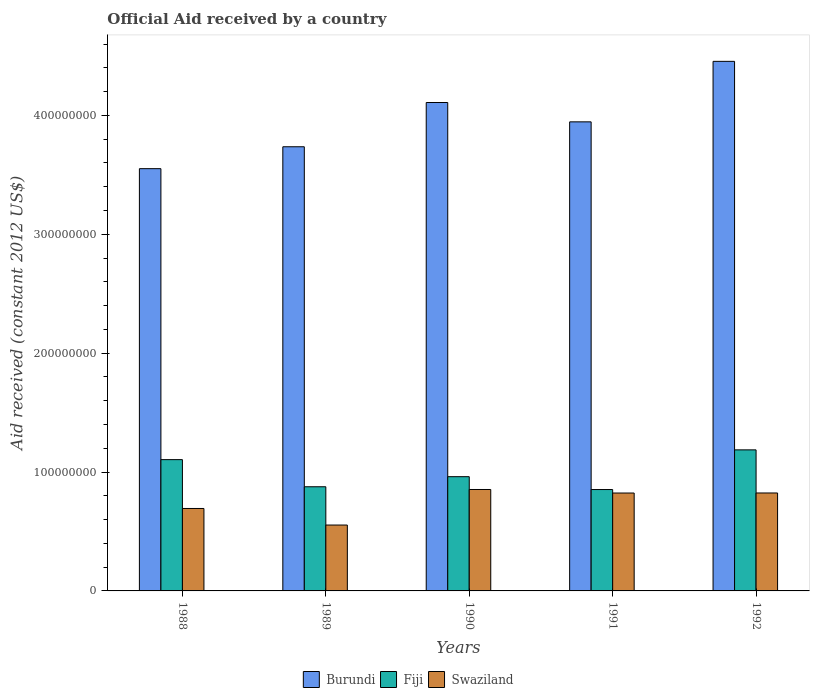How many different coloured bars are there?
Provide a short and direct response. 3. Are the number of bars per tick equal to the number of legend labels?
Ensure brevity in your answer.  Yes. What is the net official aid received in Fiji in 1988?
Your answer should be very brief. 1.10e+08. Across all years, what is the maximum net official aid received in Swaziland?
Offer a very short reply. 8.53e+07. Across all years, what is the minimum net official aid received in Swaziland?
Give a very brief answer. 5.54e+07. What is the total net official aid received in Burundi in the graph?
Offer a terse response. 1.98e+09. What is the difference between the net official aid received in Burundi in 1989 and that in 1990?
Ensure brevity in your answer.  -3.72e+07. What is the difference between the net official aid received in Swaziland in 1988 and the net official aid received in Fiji in 1992?
Your answer should be compact. -4.93e+07. What is the average net official aid received in Fiji per year?
Ensure brevity in your answer.  9.96e+07. In the year 1990, what is the difference between the net official aid received in Swaziland and net official aid received in Fiji?
Ensure brevity in your answer.  -1.08e+07. What is the ratio of the net official aid received in Fiji in 1988 to that in 1991?
Offer a very short reply. 1.29. Is the net official aid received in Burundi in 1988 less than that in 1990?
Give a very brief answer. Yes. What is the difference between the highest and the second highest net official aid received in Fiji?
Ensure brevity in your answer.  8.22e+06. What is the difference between the highest and the lowest net official aid received in Fiji?
Make the answer very short. 3.34e+07. Is the sum of the net official aid received in Burundi in 1991 and 1992 greater than the maximum net official aid received in Swaziland across all years?
Your response must be concise. Yes. What does the 1st bar from the left in 1990 represents?
Your response must be concise. Burundi. What does the 1st bar from the right in 1989 represents?
Your answer should be compact. Swaziland. Is it the case that in every year, the sum of the net official aid received in Fiji and net official aid received in Burundi is greater than the net official aid received in Swaziland?
Ensure brevity in your answer.  Yes. What is the difference between two consecutive major ticks on the Y-axis?
Make the answer very short. 1.00e+08. Does the graph contain any zero values?
Offer a very short reply. No. How are the legend labels stacked?
Make the answer very short. Horizontal. What is the title of the graph?
Your answer should be compact. Official Aid received by a country. What is the label or title of the Y-axis?
Make the answer very short. Aid received (constant 2012 US$). What is the Aid received (constant 2012 US$) in Burundi in 1988?
Your response must be concise. 3.55e+08. What is the Aid received (constant 2012 US$) of Fiji in 1988?
Your answer should be compact. 1.10e+08. What is the Aid received (constant 2012 US$) in Swaziland in 1988?
Your response must be concise. 6.94e+07. What is the Aid received (constant 2012 US$) in Burundi in 1989?
Make the answer very short. 3.74e+08. What is the Aid received (constant 2012 US$) in Fiji in 1989?
Keep it short and to the point. 8.76e+07. What is the Aid received (constant 2012 US$) in Swaziland in 1989?
Provide a short and direct response. 5.54e+07. What is the Aid received (constant 2012 US$) of Burundi in 1990?
Give a very brief answer. 4.11e+08. What is the Aid received (constant 2012 US$) in Fiji in 1990?
Provide a short and direct response. 9.61e+07. What is the Aid received (constant 2012 US$) of Swaziland in 1990?
Your answer should be very brief. 8.53e+07. What is the Aid received (constant 2012 US$) in Burundi in 1991?
Your answer should be very brief. 3.95e+08. What is the Aid received (constant 2012 US$) of Fiji in 1991?
Provide a short and direct response. 8.53e+07. What is the Aid received (constant 2012 US$) in Swaziland in 1991?
Your answer should be very brief. 8.24e+07. What is the Aid received (constant 2012 US$) in Burundi in 1992?
Your answer should be compact. 4.45e+08. What is the Aid received (constant 2012 US$) in Fiji in 1992?
Keep it short and to the point. 1.19e+08. What is the Aid received (constant 2012 US$) of Swaziland in 1992?
Offer a very short reply. 8.24e+07. Across all years, what is the maximum Aid received (constant 2012 US$) of Burundi?
Keep it short and to the point. 4.45e+08. Across all years, what is the maximum Aid received (constant 2012 US$) of Fiji?
Offer a very short reply. 1.19e+08. Across all years, what is the maximum Aid received (constant 2012 US$) in Swaziland?
Give a very brief answer. 8.53e+07. Across all years, what is the minimum Aid received (constant 2012 US$) of Burundi?
Your answer should be very brief. 3.55e+08. Across all years, what is the minimum Aid received (constant 2012 US$) in Fiji?
Keep it short and to the point. 8.53e+07. Across all years, what is the minimum Aid received (constant 2012 US$) in Swaziland?
Your answer should be very brief. 5.54e+07. What is the total Aid received (constant 2012 US$) of Burundi in the graph?
Your response must be concise. 1.98e+09. What is the total Aid received (constant 2012 US$) of Fiji in the graph?
Your answer should be compact. 4.98e+08. What is the total Aid received (constant 2012 US$) in Swaziland in the graph?
Ensure brevity in your answer.  3.75e+08. What is the difference between the Aid received (constant 2012 US$) in Burundi in 1988 and that in 1989?
Your answer should be very brief. -1.84e+07. What is the difference between the Aid received (constant 2012 US$) in Fiji in 1988 and that in 1989?
Your response must be concise. 2.28e+07. What is the difference between the Aid received (constant 2012 US$) in Swaziland in 1988 and that in 1989?
Your answer should be very brief. 1.39e+07. What is the difference between the Aid received (constant 2012 US$) in Burundi in 1988 and that in 1990?
Your response must be concise. -5.56e+07. What is the difference between the Aid received (constant 2012 US$) of Fiji in 1988 and that in 1990?
Your response must be concise. 1.43e+07. What is the difference between the Aid received (constant 2012 US$) of Swaziland in 1988 and that in 1990?
Make the answer very short. -1.60e+07. What is the difference between the Aid received (constant 2012 US$) in Burundi in 1988 and that in 1991?
Make the answer very short. -3.94e+07. What is the difference between the Aid received (constant 2012 US$) of Fiji in 1988 and that in 1991?
Provide a succinct answer. 2.52e+07. What is the difference between the Aid received (constant 2012 US$) of Swaziland in 1988 and that in 1991?
Provide a short and direct response. -1.30e+07. What is the difference between the Aid received (constant 2012 US$) in Burundi in 1988 and that in 1992?
Provide a short and direct response. -9.03e+07. What is the difference between the Aid received (constant 2012 US$) in Fiji in 1988 and that in 1992?
Give a very brief answer. -8.22e+06. What is the difference between the Aid received (constant 2012 US$) of Swaziland in 1988 and that in 1992?
Offer a terse response. -1.30e+07. What is the difference between the Aid received (constant 2012 US$) of Burundi in 1989 and that in 1990?
Provide a short and direct response. -3.72e+07. What is the difference between the Aid received (constant 2012 US$) in Fiji in 1989 and that in 1990?
Your response must be concise. -8.49e+06. What is the difference between the Aid received (constant 2012 US$) in Swaziland in 1989 and that in 1990?
Ensure brevity in your answer.  -2.99e+07. What is the difference between the Aid received (constant 2012 US$) of Burundi in 1989 and that in 1991?
Offer a terse response. -2.10e+07. What is the difference between the Aid received (constant 2012 US$) in Fiji in 1989 and that in 1991?
Your answer should be very brief. 2.33e+06. What is the difference between the Aid received (constant 2012 US$) of Swaziland in 1989 and that in 1991?
Provide a succinct answer. -2.69e+07. What is the difference between the Aid received (constant 2012 US$) in Burundi in 1989 and that in 1992?
Keep it short and to the point. -7.18e+07. What is the difference between the Aid received (constant 2012 US$) of Fiji in 1989 and that in 1992?
Provide a succinct answer. -3.10e+07. What is the difference between the Aid received (constant 2012 US$) in Swaziland in 1989 and that in 1992?
Your answer should be very brief. -2.70e+07. What is the difference between the Aid received (constant 2012 US$) in Burundi in 1990 and that in 1991?
Keep it short and to the point. 1.63e+07. What is the difference between the Aid received (constant 2012 US$) of Fiji in 1990 and that in 1991?
Give a very brief answer. 1.08e+07. What is the difference between the Aid received (constant 2012 US$) of Swaziland in 1990 and that in 1991?
Offer a very short reply. 2.97e+06. What is the difference between the Aid received (constant 2012 US$) in Burundi in 1990 and that in 1992?
Your answer should be compact. -3.46e+07. What is the difference between the Aid received (constant 2012 US$) of Fiji in 1990 and that in 1992?
Provide a succinct answer. -2.26e+07. What is the difference between the Aid received (constant 2012 US$) of Swaziland in 1990 and that in 1992?
Provide a short and direct response. 2.93e+06. What is the difference between the Aid received (constant 2012 US$) of Burundi in 1991 and that in 1992?
Offer a very short reply. -5.09e+07. What is the difference between the Aid received (constant 2012 US$) of Fiji in 1991 and that in 1992?
Provide a succinct answer. -3.34e+07. What is the difference between the Aid received (constant 2012 US$) of Burundi in 1988 and the Aid received (constant 2012 US$) of Fiji in 1989?
Offer a very short reply. 2.68e+08. What is the difference between the Aid received (constant 2012 US$) in Burundi in 1988 and the Aid received (constant 2012 US$) in Swaziland in 1989?
Provide a succinct answer. 3.00e+08. What is the difference between the Aid received (constant 2012 US$) in Fiji in 1988 and the Aid received (constant 2012 US$) in Swaziland in 1989?
Your answer should be very brief. 5.50e+07. What is the difference between the Aid received (constant 2012 US$) of Burundi in 1988 and the Aid received (constant 2012 US$) of Fiji in 1990?
Offer a terse response. 2.59e+08. What is the difference between the Aid received (constant 2012 US$) in Burundi in 1988 and the Aid received (constant 2012 US$) in Swaziland in 1990?
Your answer should be very brief. 2.70e+08. What is the difference between the Aid received (constant 2012 US$) in Fiji in 1988 and the Aid received (constant 2012 US$) in Swaziland in 1990?
Provide a succinct answer. 2.51e+07. What is the difference between the Aid received (constant 2012 US$) of Burundi in 1988 and the Aid received (constant 2012 US$) of Fiji in 1991?
Give a very brief answer. 2.70e+08. What is the difference between the Aid received (constant 2012 US$) in Burundi in 1988 and the Aid received (constant 2012 US$) in Swaziland in 1991?
Provide a succinct answer. 2.73e+08. What is the difference between the Aid received (constant 2012 US$) of Fiji in 1988 and the Aid received (constant 2012 US$) of Swaziland in 1991?
Make the answer very short. 2.81e+07. What is the difference between the Aid received (constant 2012 US$) of Burundi in 1988 and the Aid received (constant 2012 US$) of Fiji in 1992?
Provide a succinct answer. 2.37e+08. What is the difference between the Aid received (constant 2012 US$) in Burundi in 1988 and the Aid received (constant 2012 US$) in Swaziland in 1992?
Keep it short and to the point. 2.73e+08. What is the difference between the Aid received (constant 2012 US$) in Fiji in 1988 and the Aid received (constant 2012 US$) in Swaziland in 1992?
Offer a terse response. 2.80e+07. What is the difference between the Aid received (constant 2012 US$) in Burundi in 1989 and the Aid received (constant 2012 US$) in Fiji in 1990?
Provide a short and direct response. 2.78e+08. What is the difference between the Aid received (constant 2012 US$) of Burundi in 1989 and the Aid received (constant 2012 US$) of Swaziland in 1990?
Provide a succinct answer. 2.88e+08. What is the difference between the Aid received (constant 2012 US$) in Fiji in 1989 and the Aid received (constant 2012 US$) in Swaziland in 1990?
Your answer should be compact. 2.30e+06. What is the difference between the Aid received (constant 2012 US$) in Burundi in 1989 and the Aid received (constant 2012 US$) in Fiji in 1991?
Your answer should be compact. 2.88e+08. What is the difference between the Aid received (constant 2012 US$) in Burundi in 1989 and the Aid received (constant 2012 US$) in Swaziland in 1991?
Your answer should be very brief. 2.91e+08. What is the difference between the Aid received (constant 2012 US$) in Fiji in 1989 and the Aid received (constant 2012 US$) in Swaziland in 1991?
Your answer should be compact. 5.27e+06. What is the difference between the Aid received (constant 2012 US$) in Burundi in 1989 and the Aid received (constant 2012 US$) in Fiji in 1992?
Ensure brevity in your answer.  2.55e+08. What is the difference between the Aid received (constant 2012 US$) of Burundi in 1989 and the Aid received (constant 2012 US$) of Swaziland in 1992?
Give a very brief answer. 2.91e+08. What is the difference between the Aid received (constant 2012 US$) of Fiji in 1989 and the Aid received (constant 2012 US$) of Swaziland in 1992?
Keep it short and to the point. 5.23e+06. What is the difference between the Aid received (constant 2012 US$) of Burundi in 1990 and the Aid received (constant 2012 US$) of Fiji in 1991?
Your answer should be compact. 3.26e+08. What is the difference between the Aid received (constant 2012 US$) of Burundi in 1990 and the Aid received (constant 2012 US$) of Swaziland in 1991?
Your answer should be compact. 3.29e+08. What is the difference between the Aid received (constant 2012 US$) in Fiji in 1990 and the Aid received (constant 2012 US$) in Swaziland in 1991?
Your answer should be compact. 1.38e+07. What is the difference between the Aid received (constant 2012 US$) of Burundi in 1990 and the Aid received (constant 2012 US$) of Fiji in 1992?
Give a very brief answer. 2.92e+08. What is the difference between the Aid received (constant 2012 US$) in Burundi in 1990 and the Aid received (constant 2012 US$) in Swaziland in 1992?
Offer a terse response. 3.28e+08. What is the difference between the Aid received (constant 2012 US$) in Fiji in 1990 and the Aid received (constant 2012 US$) in Swaziland in 1992?
Keep it short and to the point. 1.37e+07. What is the difference between the Aid received (constant 2012 US$) of Burundi in 1991 and the Aid received (constant 2012 US$) of Fiji in 1992?
Your response must be concise. 2.76e+08. What is the difference between the Aid received (constant 2012 US$) in Burundi in 1991 and the Aid received (constant 2012 US$) in Swaziland in 1992?
Keep it short and to the point. 3.12e+08. What is the difference between the Aid received (constant 2012 US$) of Fiji in 1991 and the Aid received (constant 2012 US$) of Swaziland in 1992?
Keep it short and to the point. 2.90e+06. What is the average Aid received (constant 2012 US$) of Burundi per year?
Provide a succinct answer. 3.96e+08. What is the average Aid received (constant 2012 US$) in Fiji per year?
Provide a succinct answer. 9.96e+07. What is the average Aid received (constant 2012 US$) of Swaziland per year?
Ensure brevity in your answer.  7.50e+07. In the year 1988, what is the difference between the Aid received (constant 2012 US$) of Burundi and Aid received (constant 2012 US$) of Fiji?
Provide a short and direct response. 2.45e+08. In the year 1988, what is the difference between the Aid received (constant 2012 US$) of Burundi and Aid received (constant 2012 US$) of Swaziland?
Give a very brief answer. 2.86e+08. In the year 1988, what is the difference between the Aid received (constant 2012 US$) of Fiji and Aid received (constant 2012 US$) of Swaziland?
Make the answer very short. 4.11e+07. In the year 1989, what is the difference between the Aid received (constant 2012 US$) of Burundi and Aid received (constant 2012 US$) of Fiji?
Your response must be concise. 2.86e+08. In the year 1989, what is the difference between the Aid received (constant 2012 US$) in Burundi and Aid received (constant 2012 US$) in Swaziland?
Provide a succinct answer. 3.18e+08. In the year 1989, what is the difference between the Aid received (constant 2012 US$) of Fiji and Aid received (constant 2012 US$) of Swaziland?
Make the answer very short. 3.22e+07. In the year 1990, what is the difference between the Aid received (constant 2012 US$) of Burundi and Aid received (constant 2012 US$) of Fiji?
Ensure brevity in your answer.  3.15e+08. In the year 1990, what is the difference between the Aid received (constant 2012 US$) of Burundi and Aid received (constant 2012 US$) of Swaziland?
Give a very brief answer. 3.26e+08. In the year 1990, what is the difference between the Aid received (constant 2012 US$) in Fiji and Aid received (constant 2012 US$) in Swaziland?
Give a very brief answer. 1.08e+07. In the year 1991, what is the difference between the Aid received (constant 2012 US$) of Burundi and Aid received (constant 2012 US$) of Fiji?
Your answer should be compact. 3.09e+08. In the year 1991, what is the difference between the Aid received (constant 2012 US$) of Burundi and Aid received (constant 2012 US$) of Swaziland?
Keep it short and to the point. 3.12e+08. In the year 1991, what is the difference between the Aid received (constant 2012 US$) of Fiji and Aid received (constant 2012 US$) of Swaziland?
Keep it short and to the point. 2.94e+06. In the year 1992, what is the difference between the Aid received (constant 2012 US$) of Burundi and Aid received (constant 2012 US$) of Fiji?
Give a very brief answer. 3.27e+08. In the year 1992, what is the difference between the Aid received (constant 2012 US$) of Burundi and Aid received (constant 2012 US$) of Swaziland?
Ensure brevity in your answer.  3.63e+08. In the year 1992, what is the difference between the Aid received (constant 2012 US$) in Fiji and Aid received (constant 2012 US$) in Swaziland?
Give a very brief answer. 3.63e+07. What is the ratio of the Aid received (constant 2012 US$) of Burundi in 1988 to that in 1989?
Your answer should be very brief. 0.95. What is the ratio of the Aid received (constant 2012 US$) in Fiji in 1988 to that in 1989?
Provide a succinct answer. 1.26. What is the ratio of the Aid received (constant 2012 US$) in Swaziland in 1988 to that in 1989?
Give a very brief answer. 1.25. What is the ratio of the Aid received (constant 2012 US$) of Burundi in 1988 to that in 1990?
Offer a very short reply. 0.86. What is the ratio of the Aid received (constant 2012 US$) in Fiji in 1988 to that in 1990?
Ensure brevity in your answer.  1.15. What is the ratio of the Aid received (constant 2012 US$) of Swaziland in 1988 to that in 1990?
Your answer should be compact. 0.81. What is the ratio of the Aid received (constant 2012 US$) of Burundi in 1988 to that in 1991?
Provide a succinct answer. 0.9. What is the ratio of the Aid received (constant 2012 US$) in Fiji in 1988 to that in 1991?
Provide a succinct answer. 1.29. What is the ratio of the Aid received (constant 2012 US$) in Swaziland in 1988 to that in 1991?
Offer a terse response. 0.84. What is the ratio of the Aid received (constant 2012 US$) in Burundi in 1988 to that in 1992?
Offer a very short reply. 0.8. What is the ratio of the Aid received (constant 2012 US$) in Fiji in 1988 to that in 1992?
Provide a short and direct response. 0.93. What is the ratio of the Aid received (constant 2012 US$) of Swaziland in 1988 to that in 1992?
Provide a succinct answer. 0.84. What is the ratio of the Aid received (constant 2012 US$) in Burundi in 1989 to that in 1990?
Ensure brevity in your answer.  0.91. What is the ratio of the Aid received (constant 2012 US$) of Fiji in 1989 to that in 1990?
Make the answer very short. 0.91. What is the ratio of the Aid received (constant 2012 US$) of Swaziland in 1989 to that in 1990?
Give a very brief answer. 0.65. What is the ratio of the Aid received (constant 2012 US$) in Burundi in 1989 to that in 1991?
Provide a succinct answer. 0.95. What is the ratio of the Aid received (constant 2012 US$) in Fiji in 1989 to that in 1991?
Your answer should be compact. 1.03. What is the ratio of the Aid received (constant 2012 US$) of Swaziland in 1989 to that in 1991?
Your response must be concise. 0.67. What is the ratio of the Aid received (constant 2012 US$) of Burundi in 1989 to that in 1992?
Ensure brevity in your answer.  0.84. What is the ratio of the Aid received (constant 2012 US$) in Fiji in 1989 to that in 1992?
Provide a short and direct response. 0.74. What is the ratio of the Aid received (constant 2012 US$) of Swaziland in 1989 to that in 1992?
Provide a succinct answer. 0.67. What is the ratio of the Aid received (constant 2012 US$) in Burundi in 1990 to that in 1991?
Provide a succinct answer. 1.04. What is the ratio of the Aid received (constant 2012 US$) of Fiji in 1990 to that in 1991?
Offer a very short reply. 1.13. What is the ratio of the Aid received (constant 2012 US$) of Swaziland in 1990 to that in 1991?
Offer a terse response. 1.04. What is the ratio of the Aid received (constant 2012 US$) of Burundi in 1990 to that in 1992?
Your answer should be compact. 0.92. What is the ratio of the Aid received (constant 2012 US$) of Fiji in 1990 to that in 1992?
Your answer should be very brief. 0.81. What is the ratio of the Aid received (constant 2012 US$) in Swaziland in 1990 to that in 1992?
Your answer should be compact. 1.04. What is the ratio of the Aid received (constant 2012 US$) of Burundi in 1991 to that in 1992?
Your answer should be very brief. 0.89. What is the ratio of the Aid received (constant 2012 US$) of Fiji in 1991 to that in 1992?
Make the answer very short. 0.72. What is the ratio of the Aid received (constant 2012 US$) of Swaziland in 1991 to that in 1992?
Provide a short and direct response. 1. What is the difference between the highest and the second highest Aid received (constant 2012 US$) of Burundi?
Keep it short and to the point. 3.46e+07. What is the difference between the highest and the second highest Aid received (constant 2012 US$) of Fiji?
Make the answer very short. 8.22e+06. What is the difference between the highest and the second highest Aid received (constant 2012 US$) in Swaziland?
Provide a succinct answer. 2.93e+06. What is the difference between the highest and the lowest Aid received (constant 2012 US$) of Burundi?
Your response must be concise. 9.03e+07. What is the difference between the highest and the lowest Aid received (constant 2012 US$) in Fiji?
Your answer should be compact. 3.34e+07. What is the difference between the highest and the lowest Aid received (constant 2012 US$) of Swaziland?
Make the answer very short. 2.99e+07. 